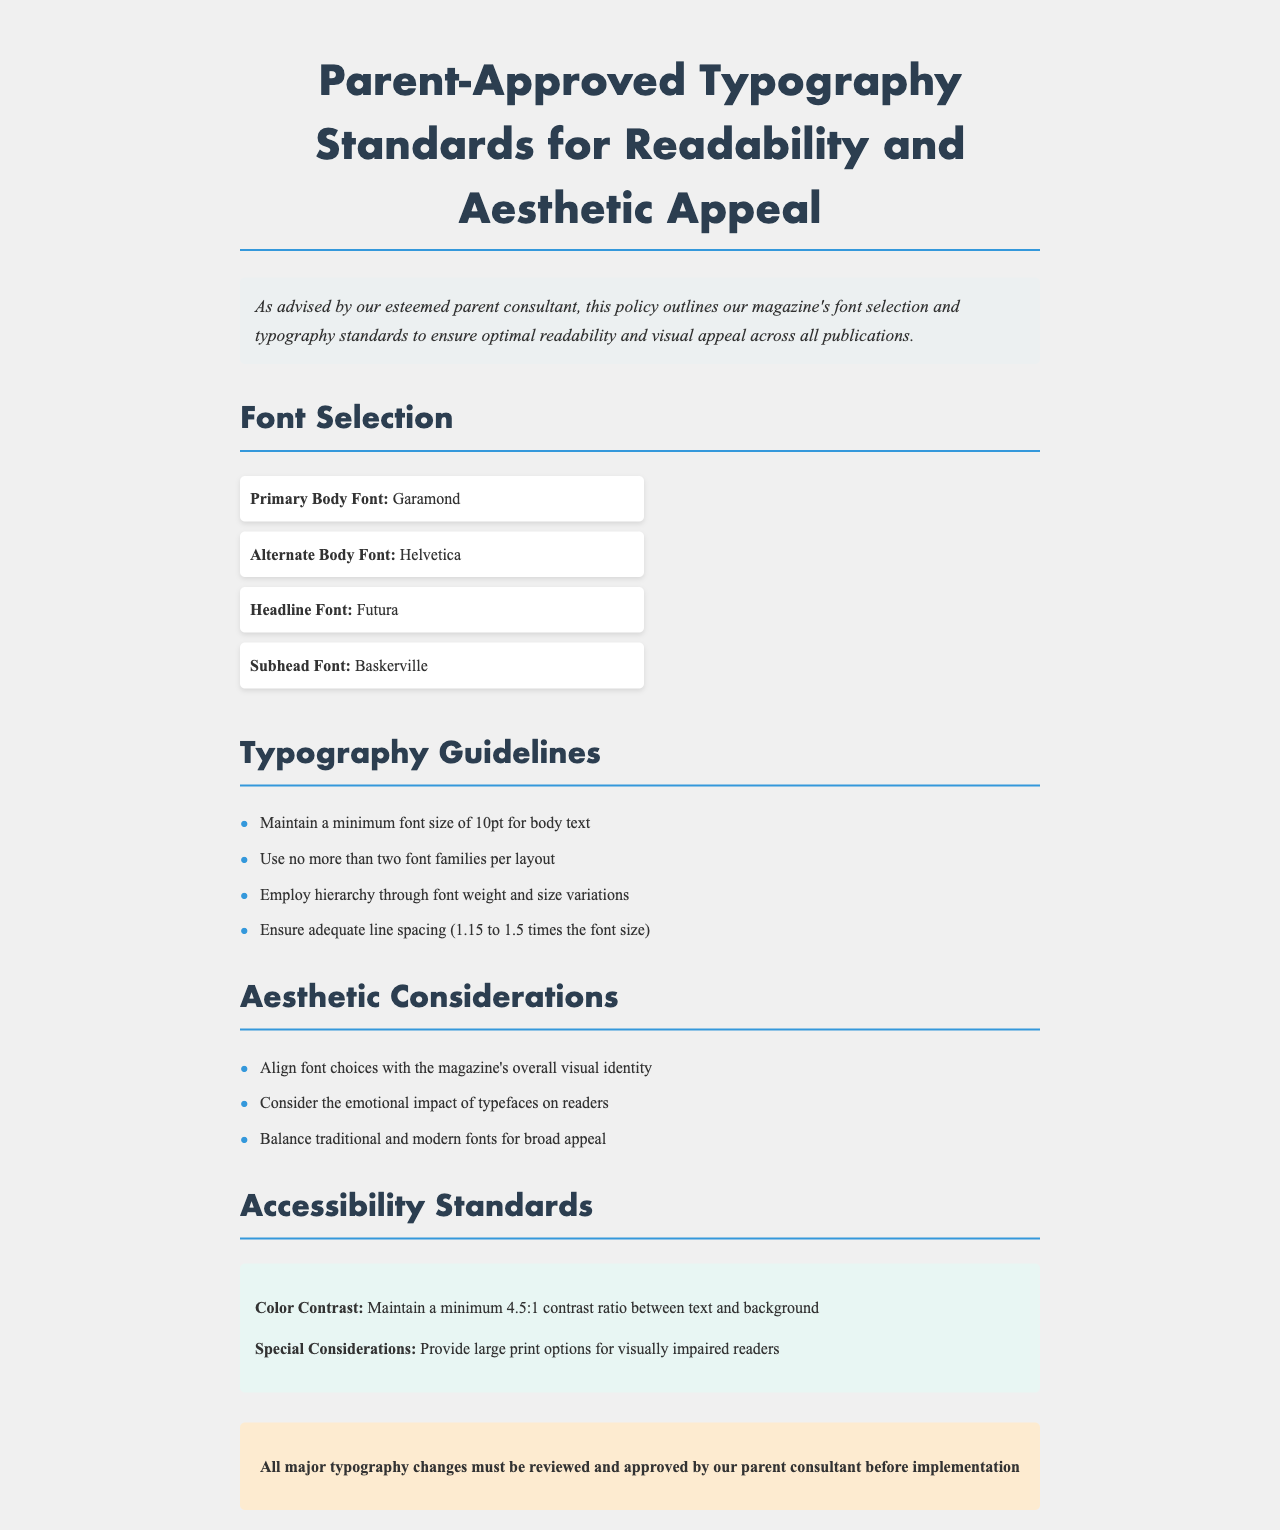What is the primary body font? The primary body font is Garamond, as specified in the document.
Answer: Garamond What is the minimum font size for body text? The document states to maintain a minimum font size of 10pt for body text.
Answer: 10pt How many font families are allowed per layout? The policy outlines that no more than two font families should be used per layout.
Answer: Two What is the required line spacing for typography? The guidelines specify adequate line spacing should be between 1.15 to 1.5 times the font size.
Answer: 1.15 to 1.5 times the font size Which font is designated for headlines? The headline font specified in the policy document is Futura.
Answer: Futura What color contrast ratio must be maintained? The document requires a minimum 4.5:1 contrast ratio between text and background.
Answer: 4.5:1 Who must approve major typography changes? The document specifies that all major typography changes must be reviewed and approved by the parent consultant.
Answer: Parent consultant What is the purpose of the aesthetic considerations section? The section outlines considerations to ensure font choices align with the magazine's visual identity and appeal.
Answer: Align with the magazine's visual identity What is the special consideration mentioned for visually impaired readers? The document indicates that large print options should be provided for visually impaired readers.
Answer: Large print options 